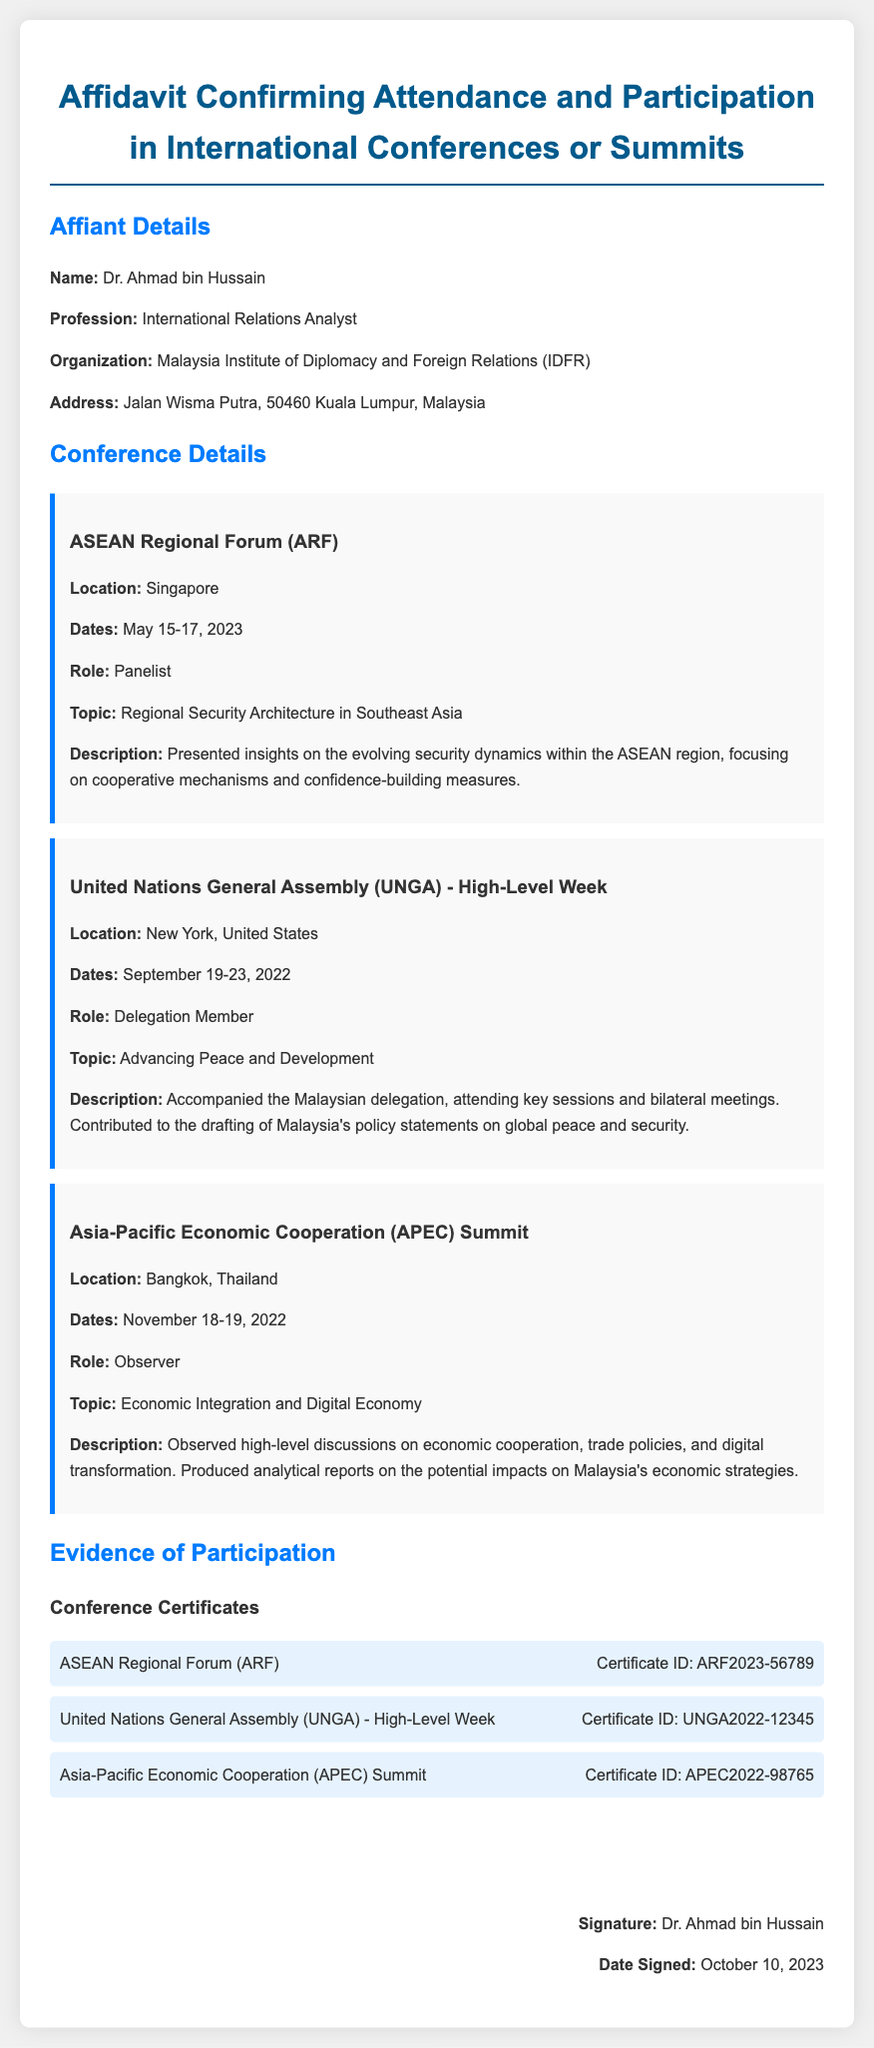What is the name of the affiant? The affiant's name is listed in the document as the individual providing the affidavit, which is Dr. Ahmad bin Hussain.
Answer: Dr. Ahmad bin Hussain What is the profession of the affiant? The profession stated in the document indicates the affiant's role, which is International Relations Analyst.
Answer: International Relations Analyst Which organization is the affiant associated with? The organization mentioned in the document to which the affiant belongs is the Malaysia Institute of Diplomacy and Foreign Relations.
Answer: Malaysia Institute of Diplomacy and Foreign Relations (IDFR) What conference did the affiant participate in as a panelist? The document specifies that the affiant served as a panelist at the ASEAN Regional Forum.
Answer: ASEAN Regional Forum (ARF) When was the United Nations General Assembly High-Level Week held? The dates of the event are provided in the document as September 19-23, 2022.
Answer: September 19-23, 2022 How many conferences are listed in the affidavit? The document contains three distinct conference entries highlighting the affiant's participation.
Answer: Three What role did the affiant have at the APEC Summit? The document categorizes the affiant's role at the APEC Summit as Observer.
Answer: Observer What was the topic of the ASEAN Regional Forum? The detailed conference information indicates that the topic was Regional Security Architecture in Southeast Asia.
Answer: Regional Security Architecture in Southeast Asia What is the Certificate ID for the APEC Summit? The document specifies the Certificate ID for the APEC Summit as APEC2022-98765.
Answer: APEC2022-98765 